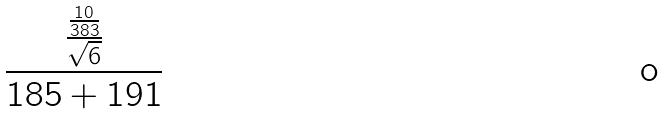Convert formula to latex. <formula><loc_0><loc_0><loc_500><loc_500>\frac { \frac { \frac { 1 0 } { 3 8 3 } } { \sqrt { 6 } } } { 1 8 5 + 1 9 1 }</formula> 